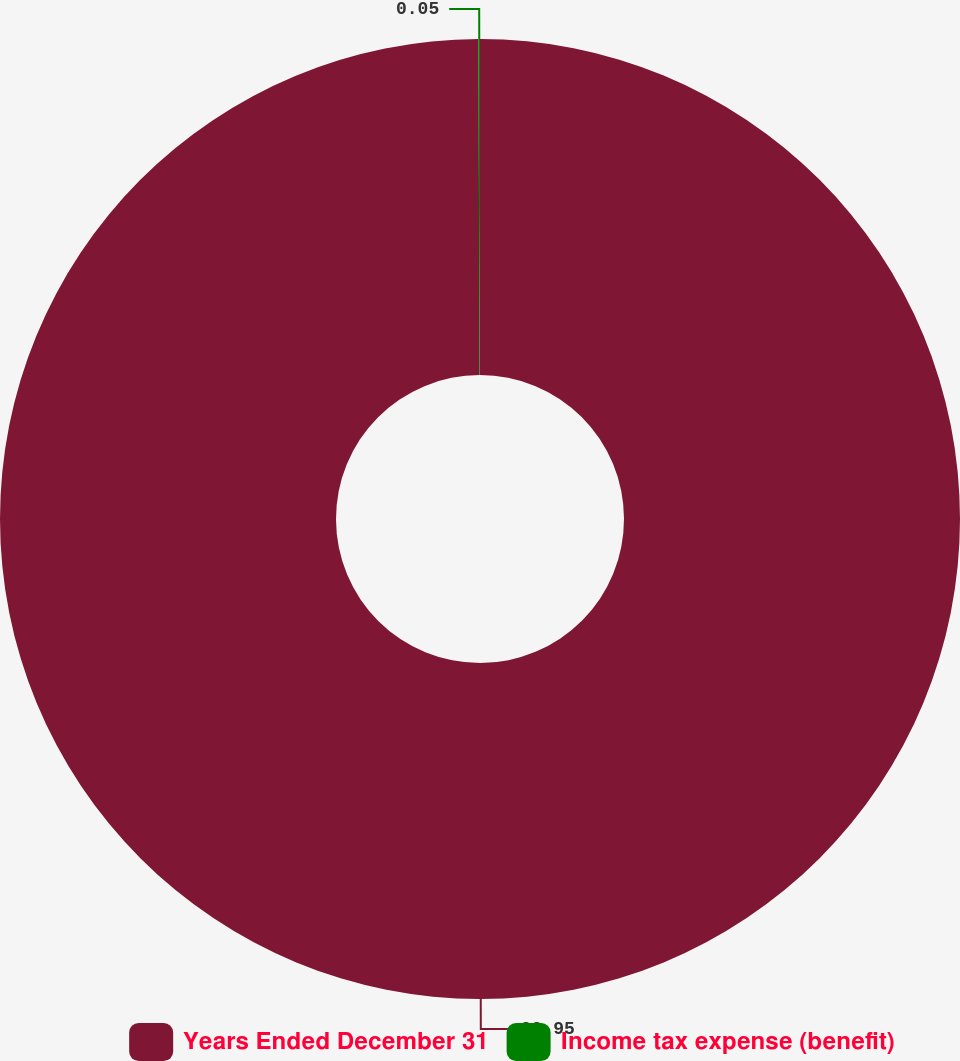<chart> <loc_0><loc_0><loc_500><loc_500><pie_chart><fcel>Years Ended December 31<fcel>Income tax expense (benefit)<nl><fcel>99.95%<fcel>0.05%<nl></chart> 